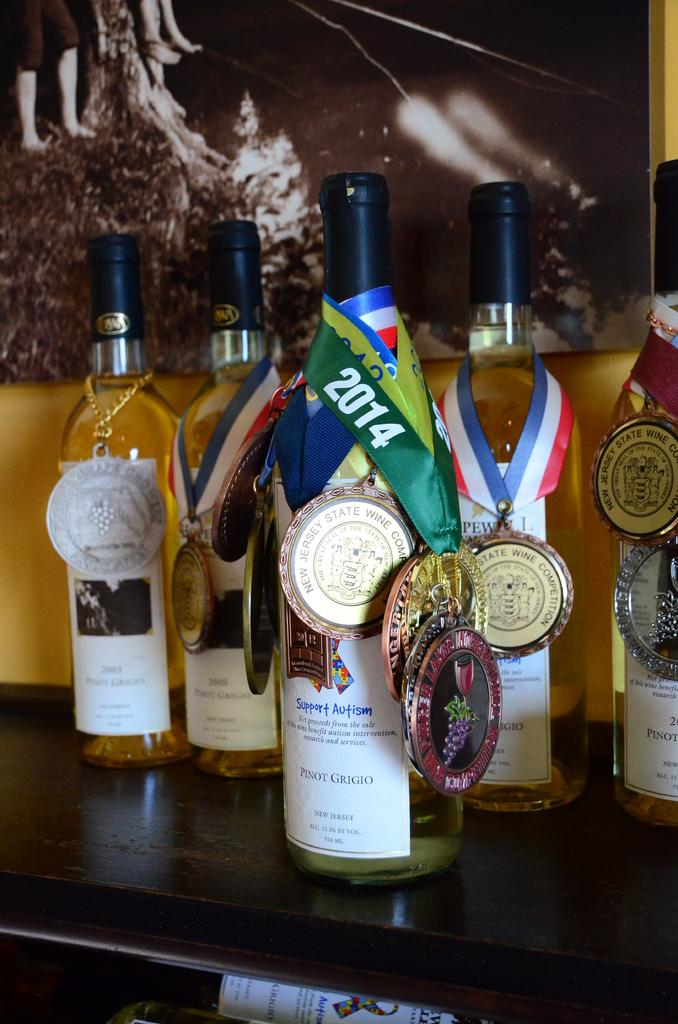<image>
Describe the image concisely. A bottle of wine has multiple medals on it, including one that says 2014 on the ribbon. 